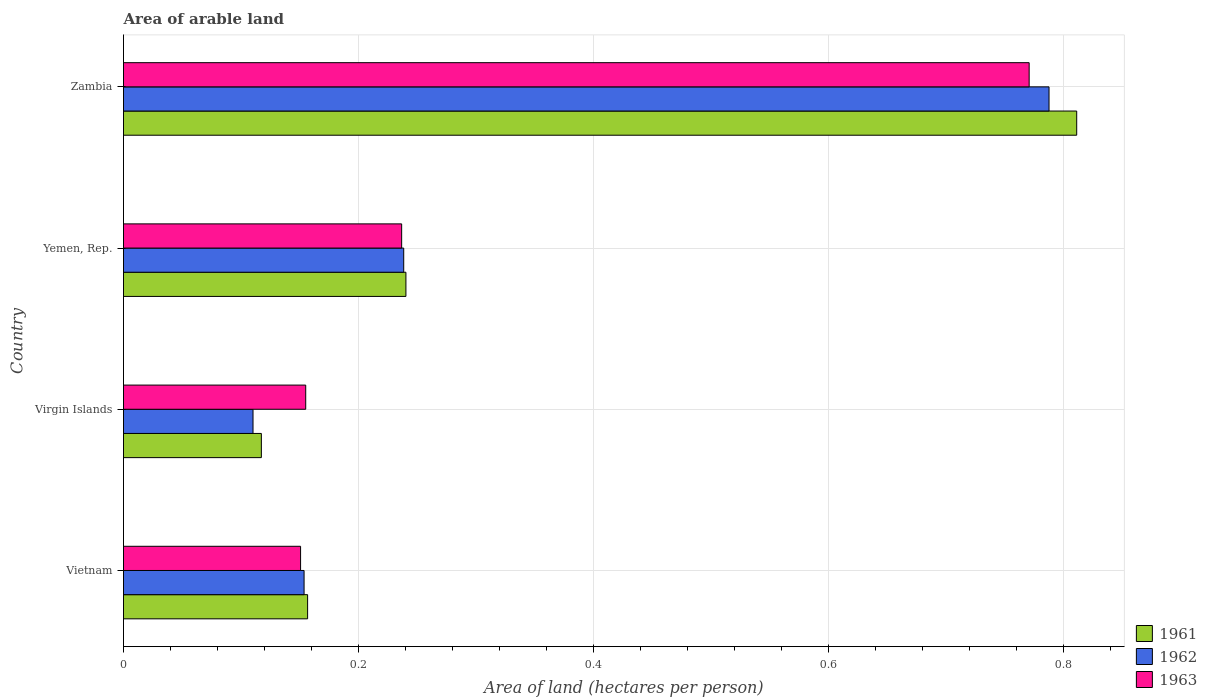Are the number of bars per tick equal to the number of legend labels?
Provide a short and direct response. Yes. How many bars are there on the 4th tick from the bottom?
Your answer should be very brief. 3. What is the label of the 4th group of bars from the top?
Your answer should be very brief. Vietnam. What is the total arable land in 1962 in Virgin Islands?
Give a very brief answer. 0.11. Across all countries, what is the maximum total arable land in 1961?
Offer a terse response. 0.81. Across all countries, what is the minimum total arable land in 1961?
Provide a short and direct response. 0.12. In which country was the total arable land in 1963 maximum?
Provide a short and direct response. Zambia. In which country was the total arable land in 1962 minimum?
Offer a terse response. Virgin Islands. What is the total total arable land in 1961 in the graph?
Offer a terse response. 1.33. What is the difference between the total arable land in 1961 in Yemen, Rep. and that in Zambia?
Offer a very short reply. -0.57. What is the difference between the total arable land in 1961 in Vietnam and the total arable land in 1962 in Zambia?
Offer a very short reply. -0.63. What is the average total arable land in 1961 per country?
Your answer should be very brief. 0.33. What is the difference between the total arable land in 1963 and total arable land in 1961 in Virgin Islands?
Make the answer very short. 0.04. What is the ratio of the total arable land in 1961 in Vietnam to that in Virgin Islands?
Keep it short and to the point. 1.34. Is the difference between the total arable land in 1963 in Virgin Islands and Yemen, Rep. greater than the difference between the total arable land in 1961 in Virgin Islands and Yemen, Rep.?
Keep it short and to the point. Yes. What is the difference between the highest and the second highest total arable land in 1963?
Ensure brevity in your answer.  0.53. What is the difference between the highest and the lowest total arable land in 1963?
Your answer should be compact. 0.62. Is it the case that in every country, the sum of the total arable land in 1961 and total arable land in 1962 is greater than the total arable land in 1963?
Give a very brief answer. Yes. How many bars are there?
Keep it short and to the point. 12. How many countries are there in the graph?
Give a very brief answer. 4. Does the graph contain any zero values?
Your response must be concise. No. Does the graph contain grids?
Provide a short and direct response. Yes. Where does the legend appear in the graph?
Your answer should be very brief. Bottom right. How many legend labels are there?
Your answer should be very brief. 3. What is the title of the graph?
Make the answer very short. Area of arable land. Does "1980" appear as one of the legend labels in the graph?
Make the answer very short. No. What is the label or title of the X-axis?
Your answer should be very brief. Area of land (hectares per person). What is the Area of land (hectares per person) of 1961 in Vietnam?
Give a very brief answer. 0.16. What is the Area of land (hectares per person) in 1962 in Vietnam?
Your answer should be very brief. 0.15. What is the Area of land (hectares per person) in 1963 in Vietnam?
Make the answer very short. 0.15. What is the Area of land (hectares per person) of 1961 in Virgin Islands?
Your response must be concise. 0.12. What is the Area of land (hectares per person) of 1962 in Virgin Islands?
Provide a short and direct response. 0.11. What is the Area of land (hectares per person) in 1963 in Virgin Islands?
Provide a short and direct response. 0.16. What is the Area of land (hectares per person) in 1961 in Yemen, Rep.?
Offer a terse response. 0.24. What is the Area of land (hectares per person) in 1962 in Yemen, Rep.?
Give a very brief answer. 0.24. What is the Area of land (hectares per person) in 1963 in Yemen, Rep.?
Ensure brevity in your answer.  0.24. What is the Area of land (hectares per person) of 1961 in Zambia?
Your answer should be compact. 0.81. What is the Area of land (hectares per person) of 1962 in Zambia?
Give a very brief answer. 0.79. What is the Area of land (hectares per person) of 1963 in Zambia?
Keep it short and to the point. 0.77. Across all countries, what is the maximum Area of land (hectares per person) of 1961?
Make the answer very short. 0.81. Across all countries, what is the maximum Area of land (hectares per person) of 1962?
Your response must be concise. 0.79. Across all countries, what is the maximum Area of land (hectares per person) in 1963?
Offer a very short reply. 0.77. Across all countries, what is the minimum Area of land (hectares per person) in 1961?
Your answer should be very brief. 0.12. Across all countries, what is the minimum Area of land (hectares per person) of 1962?
Your answer should be very brief. 0.11. Across all countries, what is the minimum Area of land (hectares per person) of 1963?
Give a very brief answer. 0.15. What is the total Area of land (hectares per person) of 1961 in the graph?
Your answer should be very brief. 1.33. What is the total Area of land (hectares per person) of 1962 in the graph?
Your response must be concise. 1.29. What is the total Area of land (hectares per person) in 1963 in the graph?
Offer a very short reply. 1.31. What is the difference between the Area of land (hectares per person) of 1961 in Vietnam and that in Virgin Islands?
Give a very brief answer. 0.04. What is the difference between the Area of land (hectares per person) of 1962 in Vietnam and that in Virgin Islands?
Offer a very short reply. 0.04. What is the difference between the Area of land (hectares per person) in 1963 in Vietnam and that in Virgin Islands?
Your answer should be very brief. -0. What is the difference between the Area of land (hectares per person) in 1961 in Vietnam and that in Yemen, Rep.?
Ensure brevity in your answer.  -0.08. What is the difference between the Area of land (hectares per person) in 1962 in Vietnam and that in Yemen, Rep.?
Your answer should be very brief. -0.08. What is the difference between the Area of land (hectares per person) in 1963 in Vietnam and that in Yemen, Rep.?
Your answer should be compact. -0.09. What is the difference between the Area of land (hectares per person) of 1961 in Vietnam and that in Zambia?
Make the answer very short. -0.65. What is the difference between the Area of land (hectares per person) of 1962 in Vietnam and that in Zambia?
Your answer should be very brief. -0.63. What is the difference between the Area of land (hectares per person) of 1963 in Vietnam and that in Zambia?
Provide a succinct answer. -0.62. What is the difference between the Area of land (hectares per person) of 1961 in Virgin Islands and that in Yemen, Rep.?
Offer a terse response. -0.12. What is the difference between the Area of land (hectares per person) in 1962 in Virgin Islands and that in Yemen, Rep.?
Provide a short and direct response. -0.13. What is the difference between the Area of land (hectares per person) in 1963 in Virgin Islands and that in Yemen, Rep.?
Keep it short and to the point. -0.08. What is the difference between the Area of land (hectares per person) in 1961 in Virgin Islands and that in Zambia?
Your answer should be very brief. -0.69. What is the difference between the Area of land (hectares per person) of 1962 in Virgin Islands and that in Zambia?
Make the answer very short. -0.68. What is the difference between the Area of land (hectares per person) of 1963 in Virgin Islands and that in Zambia?
Your answer should be compact. -0.62. What is the difference between the Area of land (hectares per person) in 1961 in Yemen, Rep. and that in Zambia?
Offer a terse response. -0.57. What is the difference between the Area of land (hectares per person) in 1962 in Yemen, Rep. and that in Zambia?
Offer a very short reply. -0.55. What is the difference between the Area of land (hectares per person) of 1963 in Yemen, Rep. and that in Zambia?
Make the answer very short. -0.53. What is the difference between the Area of land (hectares per person) of 1961 in Vietnam and the Area of land (hectares per person) of 1962 in Virgin Islands?
Keep it short and to the point. 0.05. What is the difference between the Area of land (hectares per person) of 1961 in Vietnam and the Area of land (hectares per person) of 1963 in Virgin Islands?
Offer a terse response. 0. What is the difference between the Area of land (hectares per person) of 1962 in Vietnam and the Area of land (hectares per person) of 1963 in Virgin Islands?
Offer a terse response. -0. What is the difference between the Area of land (hectares per person) in 1961 in Vietnam and the Area of land (hectares per person) in 1962 in Yemen, Rep.?
Make the answer very short. -0.08. What is the difference between the Area of land (hectares per person) of 1961 in Vietnam and the Area of land (hectares per person) of 1963 in Yemen, Rep.?
Offer a very short reply. -0.08. What is the difference between the Area of land (hectares per person) in 1962 in Vietnam and the Area of land (hectares per person) in 1963 in Yemen, Rep.?
Offer a terse response. -0.08. What is the difference between the Area of land (hectares per person) in 1961 in Vietnam and the Area of land (hectares per person) in 1962 in Zambia?
Offer a very short reply. -0.63. What is the difference between the Area of land (hectares per person) of 1961 in Vietnam and the Area of land (hectares per person) of 1963 in Zambia?
Offer a terse response. -0.61. What is the difference between the Area of land (hectares per person) in 1962 in Vietnam and the Area of land (hectares per person) in 1963 in Zambia?
Give a very brief answer. -0.62. What is the difference between the Area of land (hectares per person) in 1961 in Virgin Islands and the Area of land (hectares per person) in 1962 in Yemen, Rep.?
Offer a terse response. -0.12. What is the difference between the Area of land (hectares per person) in 1961 in Virgin Islands and the Area of land (hectares per person) in 1963 in Yemen, Rep.?
Give a very brief answer. -0.12. What is the difference between the Area of land (hectares per person) in 1962 in Virgin Islands and the Area of land (hectares per person) in 1963 in Yemen, Rep.?
Offer a very short reply. -0.13. What is the difference between the Area of land (hectares per person) of 1961 in Virgin Islands and the Area of land (hectares per person) of 1962 in Zambia?
Provide a short and direct response. -0.67. What is the difference between the Area of land (hectares per person) in 1961 in Virgin Islands and the Area of land (hectares per person) in 1963 in Zambia?
Offer a very short reply. -0.65. What is the difference between the Area of land (hectares per person) in 1962 in Virgin Islands and the Area of land (hectares per person) in 1963 in Zambia?
Ensure brevity in your answer.  -0.66. What is the difference between the Area of land (hectares per person) in 1961 in Yemen, Rep. and the Area of land (hectares per person) in 1962 in Zambia?
Keep it short and to the point. -0.55. What is the difference between the Area of land (hectares per person) in 1961 in Yemen, Rep. and the Area of land (hectares per person) in 1963 in Zambia?
Keep it short and to the point. -0.53. What is the difference between the Area of land (hectares per person) of 1962 in Yemen, Rep. and the Area of land (hectares per person) of 1963 in Zambia?
Make the answer very short. -0.53. What is the average Area of land (hectares per person) in 1961 per country?
Provide a short and direct response. 0.33. What is the average Area of land (hectares per person) in 1962 per country?
Offer a very short reply. 0.32. What is the average Area of land (hectares per person) of 1963 per country?
Offer a very short reply. 0.33. What is the difference between the Area of land (hectares per person) in 1961 and Area of land (hectares per person) in 1962 in Vietnam?
Your answer should be very brief. 0. What is the difference between the Area of land (hectares per person) of 1961 and Area of land (hectares per person) of 1963 in Vietnam?
Make the answer very short. 0.01. What is the difference between the Area of land (hectares per person) of 1962 and Area of land (hectares per person) of 1963 in Vietnam?
Ensure brevity in your answer.  0. What is the difference between the Area of land (hectares per person) in 1961 and Area of land (hectares per person) in 1962 in Virgin Islands?
Your answer should be compact. 0.01. What is the difference between the Area of land (hectares per person) of 1961 and Area of land (hectares per person) of 1963 in Virgin Islands?
Provide a succinct answer. -0.04. What is the difference between the Area of land (hectares per person) of 1962 and Area of land (hectares per person) of 1963 in Virgin Islands?
Your answer should be very brief. -0.04. What is the difference between the Area of land (hectares per person) of 1961 and Area of land (hectares per person) of 1962 in Yemen, Rep.?
Your response must be concise. 0. What is the difference between the Area of land (hectares per person) of 1961 and Area of land (hectares per person) of 1963 in Yemen, Rep.?
Keep it short and to the point. 0. What is the difference between the Area of land (hectares per person) of 1962 and Area of land (hectares per person) of 1963 in Yemen, Rep.?
Offer a very short reply. 0. What is the difference between the Area of land (hectares per person) of 1961 and Area of land (hectares per person) of 1962 in Zambia?
Make the answer very short. 0.02. What is the difference between the Area of land (hectares per person) in 1961 and Area of land (hectares per person) in 1963 in Zambia?
Offer a terse response. 0.04. What is the difference between the Area of land (hectares per person) in 1962 and Area of land (hectares per person) in 1963 in Zambia?
Offer a terse response. 0.02. What is the ratio of the Area of land (hectares per person) in 1961 in Vietnam to that in Virgin Islands?
Offer a terse response. 1.34. What is the ratio of the Area of land (hectares per person) of 1962 in Vietnam to that in Virgin Islands?
Ensure brevity in your answer.  1.39. What is the ratio of the Area of land (hectares per person) in 1963 in Vietnam to that in Virgin Islands?
Offer a very short reply. 0.97. What is the ratio of the Area of land (hectares per person) in 1961 in Vietnam to that in Yemen, Rep.?
Keep it short and to the point. 0.65. What is the ratio of the Area of land (hectares per person) of 1962 in Vietnam to that in Yemen, Rep.?
Provide a succinct answer. 0.64. What is the ratio of the Area of land (hectares per person) of 1963 in Vietnam to that in Yemen, Rep.?
Provide a short and direct response. 0.64. What is the ratio of the Area of land (hectares per person) of 1961 in Vietnam to that in Zambia?
Offer a very short reply. 0.19. What is the ratio of the Area of land (hectares per person) of 1962 in Vietnam to that in Zambia?
Provide a succinct answer. 0.2. What is the ratio of the Area of land (hectares per person) in 1963 in Vietnam to that in Zambia?
Make the answer very short. 0.2. What is the ratio of the Area of land (hectares per person) of 1961 in Virgin Islands to that in Yemen, Rep.?
Provide a succinct answer. 0.49. What is the ratio of the Area of land (hectares per person) in 1962 in Virgin Islands to that in Yemen, Rep.?
Your answer should be very brief. 0.46. What is the ratio of the Area of land (hectares per person) in 1963 in Virgin Islands to that in Yemen, Rep.?
Offer a very short reply. 0.66. What is the ratio of the Area of land (hectares per person) in 1961 in Virgin Islands to that in Zambia?
Offer a terse response. 0.14. What is the ratio of the Area of land (hectares per person) in 1962 in Virgin Islands to that in Zambia?
Provide a short and direct response. 0.14. What is the ratio of the Area of land (hectares per person) in 1963 in Virgin Islands to that in Zambia?
Give a very brief answer. 0.2. What is the ratio of the Area of land (hectares per person) in 1961 in Yemen, Rep. to that in Zambia?
Make the answer very short. 0.3. What is the ratio of the Area of land (hectares per person) in 1962 in Yemen, Rep. to that in Zambia?
Your answer should be compact. 0.3. What is the ratio of the Area of land (hectares per person) in 1963 in Yemen, Rep. to that in Zambia?
Give a very brief answer. 0.31. What is the difference between the highest and the second highest Area of land (hectares per person) in 1961?
Offer a terse response. 0.57. What is the difference between the highest and the second highest Area of land (hectares per person) of 1962?
Your answer should be compact. 0.55. What is the difference between the highest and the second highest Area of land (hectares per person) in 1963?
Offer a very short reply. 0.53. What is the difference between the highest and the lowest Area of land (hectares per person) of 1961?
Offer a terse response. 0.69. What is the difference between the highest and the lowest Area of land (hectares per person) of 1962?
Provide a succinct answer. 0.68. What is the difference between the highest and the lowest Area of land (hectares per person) of 1963?
Provide a succinct answer. 0.62. 